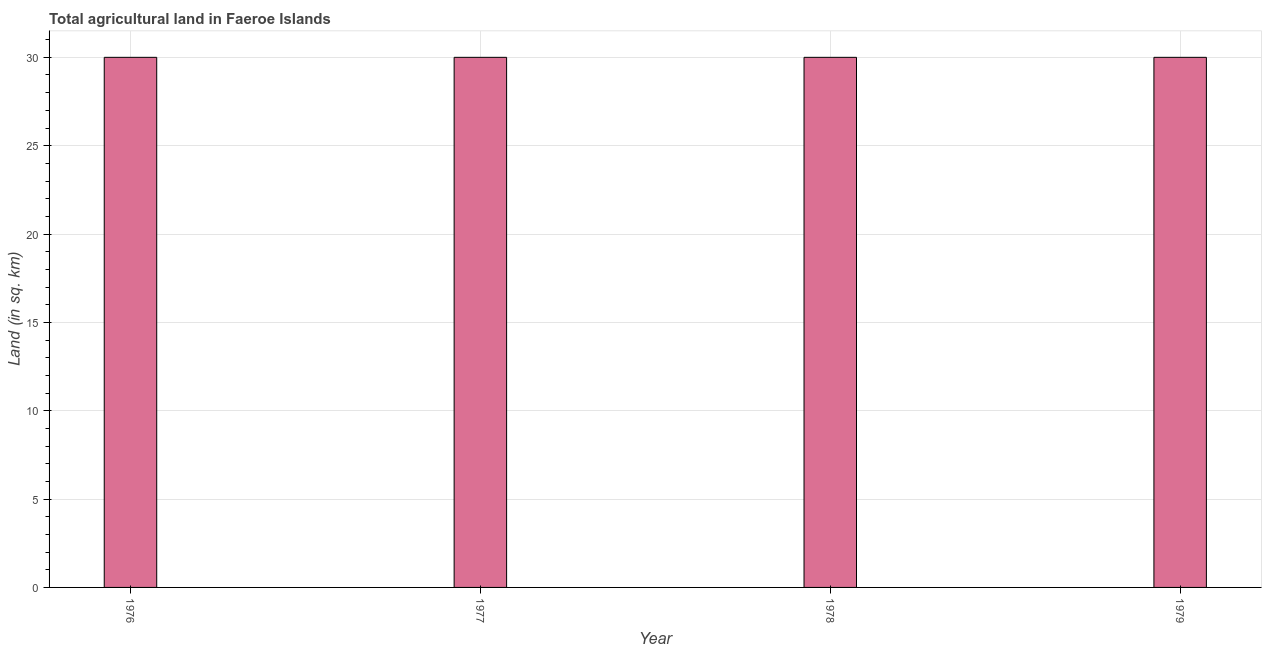Does the graph contain any zero values?
Your answer should be compact. No. What is the title of the graph?
Your answer should be compact. Total agricultural land in Faeroe Islands. What is the label or title of the X-axis?
Make the answer very short. Year. What is the label or title of the Y-axis?
Your answer should be very brief. Land (in sq. km). What is the agricultural land in 1976?
Offer a very short reply. 30. Across all years, what is the maximum agricultural land?
Offer a terse response. 30. In which year was the agricultural land maximum?
Keep it short and to the point. 1976. In which year was the agricultural land minimum?
Ensure brevity in your answer.  1976. What is the sum of the agricultural land?
Ensure brevity in your answer.  120. What is the median agricultural land?
Keep it short and to the point. 30. Do a majority of the years between 1976 and 1979 (inclusive) have agricultural land greater than 27 sq. km?
Give a very brief answer. Yes. Is the agricultural land in 1977 less than that in 1978?
Your answer should be compact. No. What is the difference between the highest and the second highest agricultural land?
Keep it short and to the point. 0. Is the sum of the agricultural land in 1976 and 1978 greater than the maximum agricultural land across all years?
Give a very brief answer. Yes. What is the difference between the highest and the lowest agricultural land?
Give a very brief answer. 0. How many bars are there?
Make the answer very short. 4. Are all the bars in the graph horizontal?
Provide a short and direct response. No. How many years are there in the graph?
Your answer should be very brief. 4. What is the difference between two consecutive major ticks on the Y-axis?
Your response must be concise. 5. Are the values on the major ticks of Y-axis written in scientific E-notation?
Provide a succinct answer. No. What is the Land (in sq. km) in 1979?
Offer a terse response. 30. What is the difference between the Land (in sq. km) in 1976 and 1979?
Your response must be concise. 0. What is the difference between the Land (in sq. km) in 1978 and 1979?
Give a very brief answer. 0. What is the ratio of the Land (in sq. km) in 1976 to that in 1979?
Offer a terse response. 1. What is the ratio of the Land (in sq. km) in 1977 to that in 1978?
Your answer should be very brief. 1. What is the ratio of the Land (in sq. km) in 1978 to that in 1979?
Provide a short and direct response. 1. 